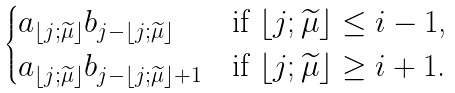Convert formula to latex. <formula><loc_0><loc_0><loc_500><loc_500>\begin{cases} a _ { \lfloor j ; \widetilde { \mu } \rfloor } b _ { j - \lfloor j ; \widetilde { \mu } \rfloor } & \text {if $\lfloor j;\widetilde{\mu}\rfloor\leq i-1$,} \\ a _ { \lfloor j ; \widetilde { \mu } \rfloor } b _ { j - \lfloor j ; \widetilde { \mu } \rfloor + 1 } & \text {if $\lfloor j;\widetilde{\mu}\rfloor\geq i+1$.} \end{cases}</formula> 